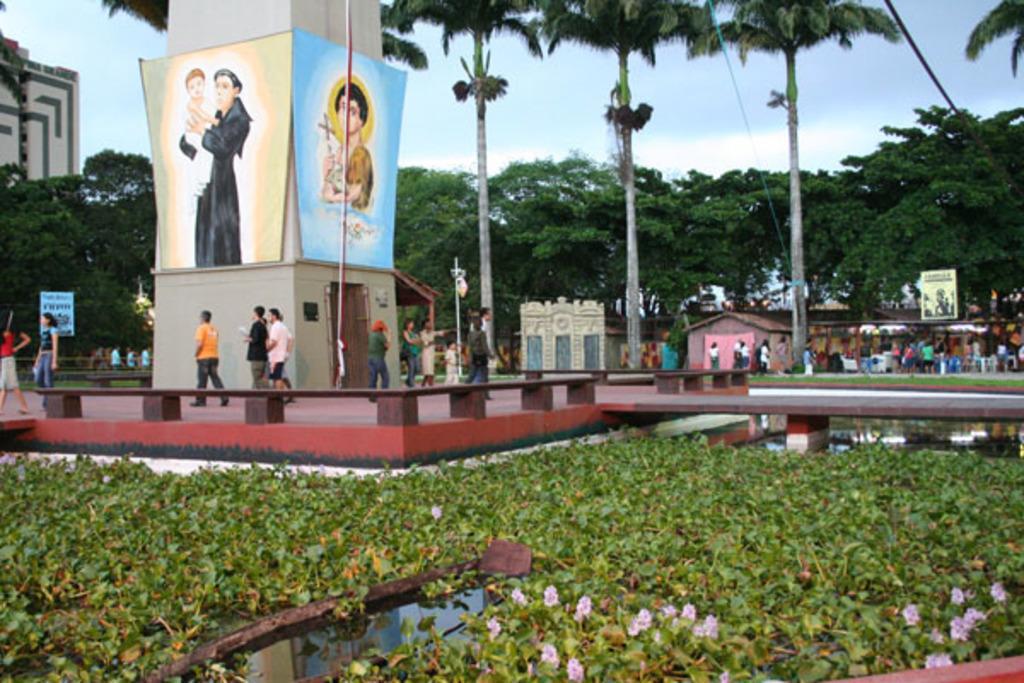Could you give a brief overview of what you see in this image? In this image I can see at the bottom there are flowers and plants. On the left side there are paintings on the wall. In the middle a group of people are there, at the back side there are trees and buildings, at the top it is the sky. 